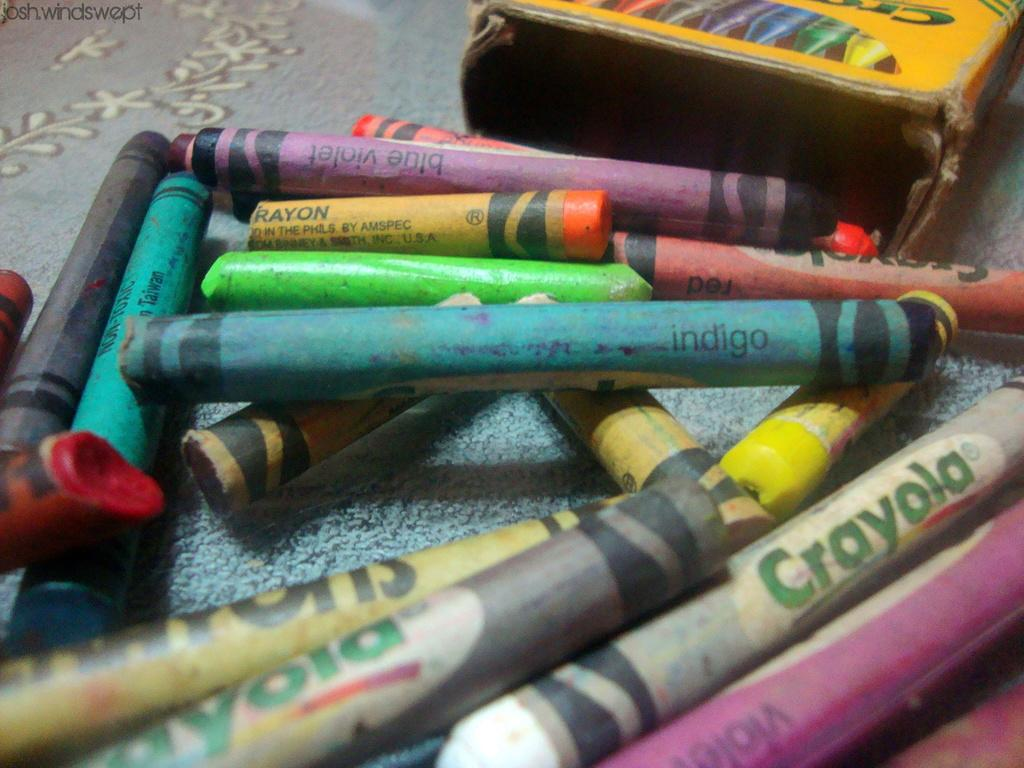What type of art supplies are present in the image? There are crayons in the image. What object is used to store or organize the crayons? There is a box in the image. On what surface are the crayons and box placed? The crayons and box are on a cloth. What type of soup is being served in the bowl on the cloth? There is no bowl or soup present in the image; it only features crayons, a box, and a cloth. 